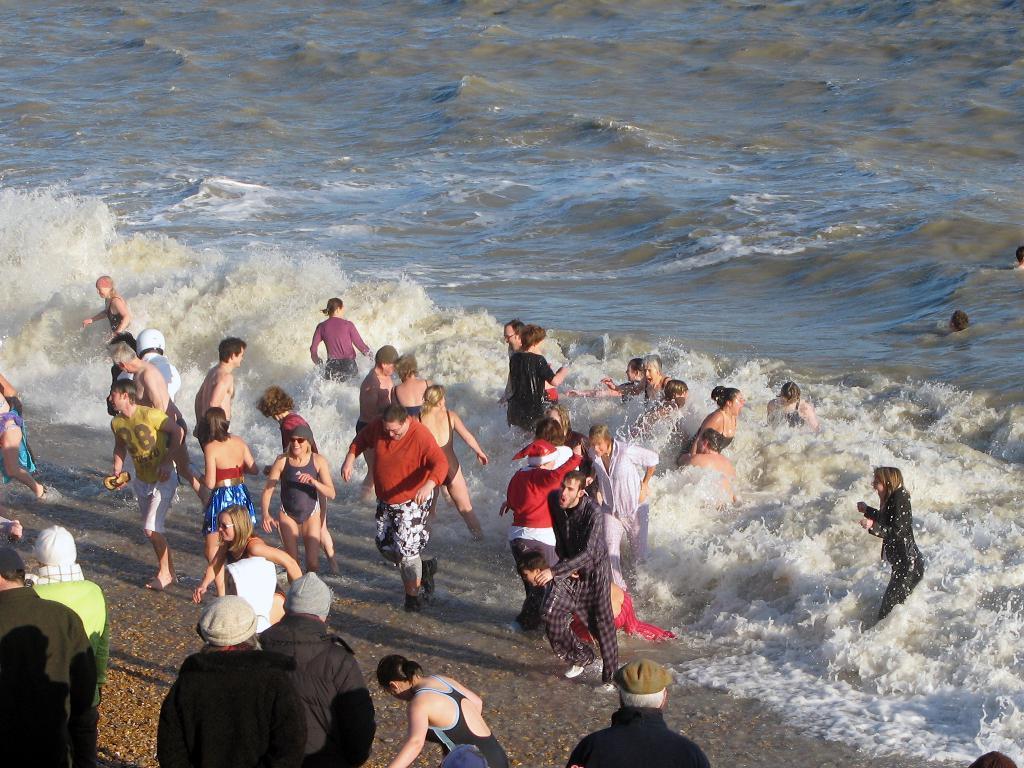Please provide a concise description of this image. In this picture there are people, among the few persons walking and we can see sand and water. 